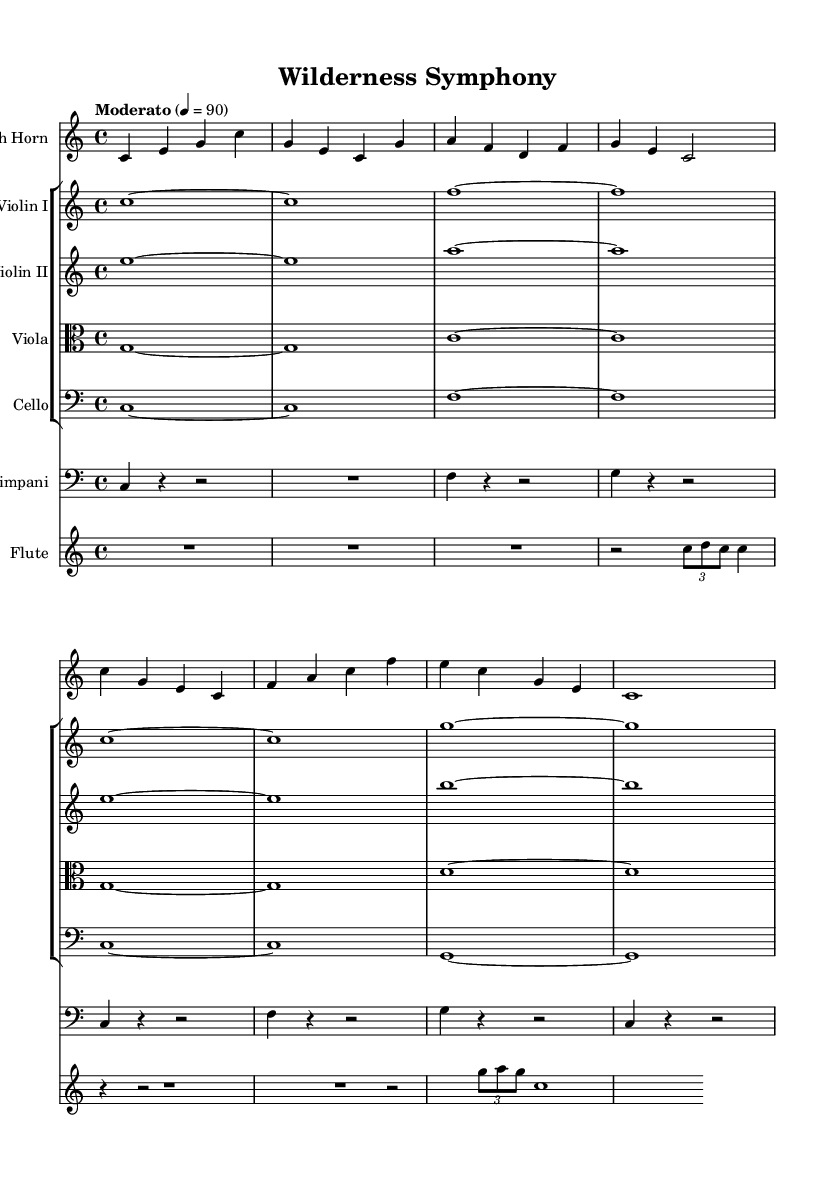What is the key signature of this music? The key signature is indicated at the beginning of the staff and shows no sharps or flats, which corresponds to C major.
Answer: C major What is the time signature of this music? The time signature is found at the beginning and is indicated as 4/4, meaning there are four beats per measure and the quarter note gets one beat.
Answer: 4/4 What is the tempo marking of this piece? The tempo marking is found within the global section and indicates a speed of 90 beats per minute, described as “Moderato.”
Answer: Moderato 4 = 90 How many different instruments are present in this score? The score includes six distinct instruments: French Horn, Violin I, Violin II, Viola, Cello, Timpani, and Flute. Counting these gives us a total of six instruments.
Answer: Six Which instrument plays the melody in the first part of the score? The French Horn plays the melody in the first section, as indicated by its placement at the top of the score and its melodic line.
Answer: French Horn What rhythmic pattern is prominently featured in the Timpani part? The Timpani part features a repeating pattern of alternating measures of quarter notes and rests, creating a rhythmic texture supporting the other instruments.
Answer: Quarter notes and rests What mood does the score convey that aligns with the theme of wilderness and national parks? The combination of lush harmonies, flowing melodic lines, and the use of woodwinds and brass conveys a majestic and serene mood, evoking the beauty of nature.
Answer: Majestic and serene 